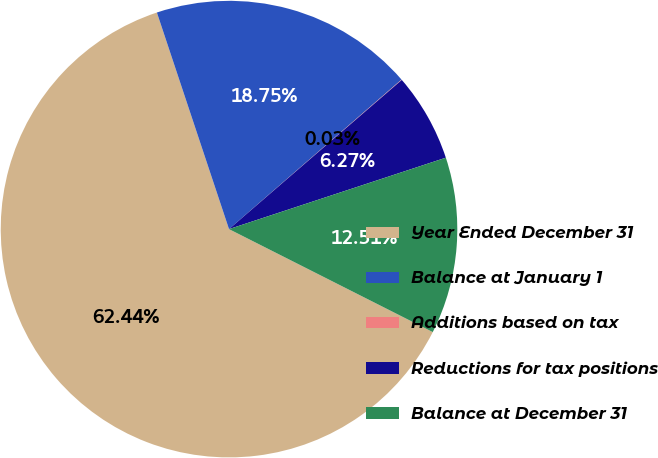Convert chart. <chart><loc_0><loc_0><loc_500><loc_500><pie_chart><fcel>Year Ended December 31<fcel>Balance at January 1<fcel>Additions based on tax<fcel>Reductions for tax positions<fcel>Balance at December 31<nl><fcel>62.43%<fcel>18.75%<fcel>0.03%<fcel>6.27%<fcel>12.51%<nl></chart> 